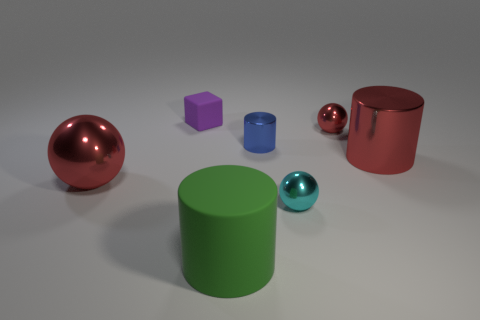Add 1 tiny blue rubber cubes. How many objects exist? 8 Subtract all shiny cylinders. How many cylinders are left? 1 Subtract 1 cylinders. How many cylinders are left? 2 Subtract all blue cylinders. How many purple balls are left? 0 Subtract all big blue matte cylinders. Subtract all red spheres. How many objects are left? 5 Add 3 tiny purple matte things. How many tiny purple matte things are left? 4 Add 7 blue metallic cylinders. How many blue metallic cylinders exist? 8 Subtract all cyan spheres. How many spheres are left? 2 Subtract 0 gray cylinders. How many objects are left? 7 Subtract all cubes. How many objects are left? 6 